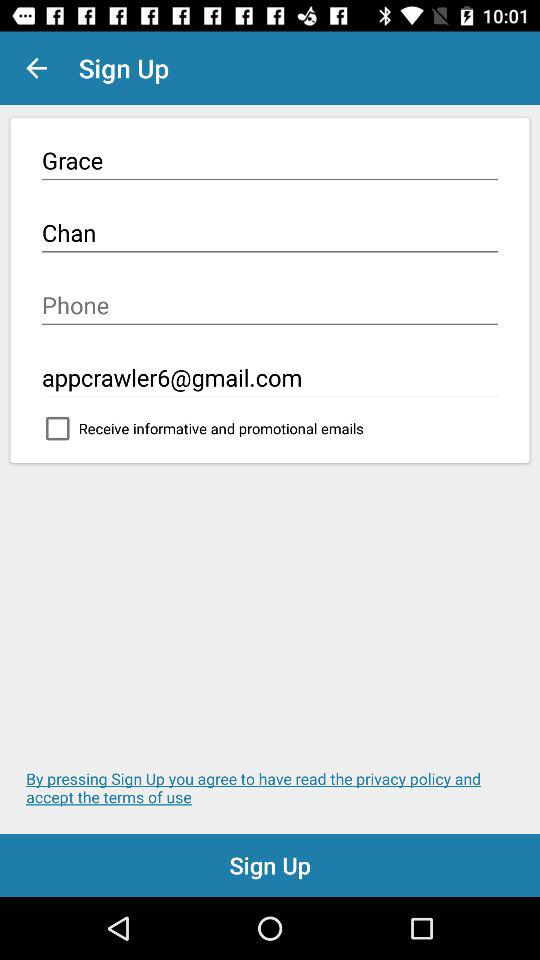What "Gmail" address is used? The used "Gmail" address is appcrawler6@gmail.com. 